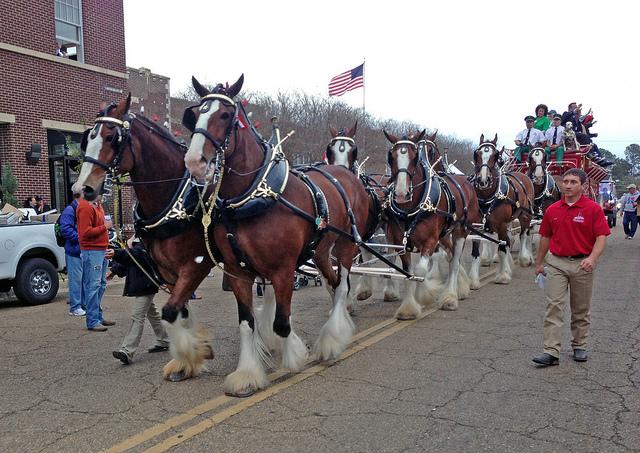What event is taking place?
Give a very brief answer. Parade. What company is associated with these animals?
Quick response, please. Budweiser. Is this a parade?
Quick response, please. Yes. Are these draft horses?
Answer briefly. Yes. Are all of these horses the same color?
Give a very brief answer. Yes. How many horses are in the picture?
Keep it brief. 7. What color is the lead horse?
Quick response, please. Brown. Is this a vintage photo?
Be succinct. No. Is this probably America?
Be succinct. Yes. What breed of horse is shown?
Give a very brief answer. Clydesdale. How many horses are in the first row?
Quick response, please. 2. What are these horses pulling?
Short answer required. Carriage. How many horses are there?
Short answer required. 8. How many white horses do you see?
Give a very brief answer. 0. What kinds of animals are these?
Be succinct. Horses. What are the animals and their handlers standing on?
Answer briefly. Street. How many horses?
Be succinct. 8. Where is the horse carriage?
Answer briefly. Street. Who is the horse handler?
Give a very brief answer. Man in red shirt. 